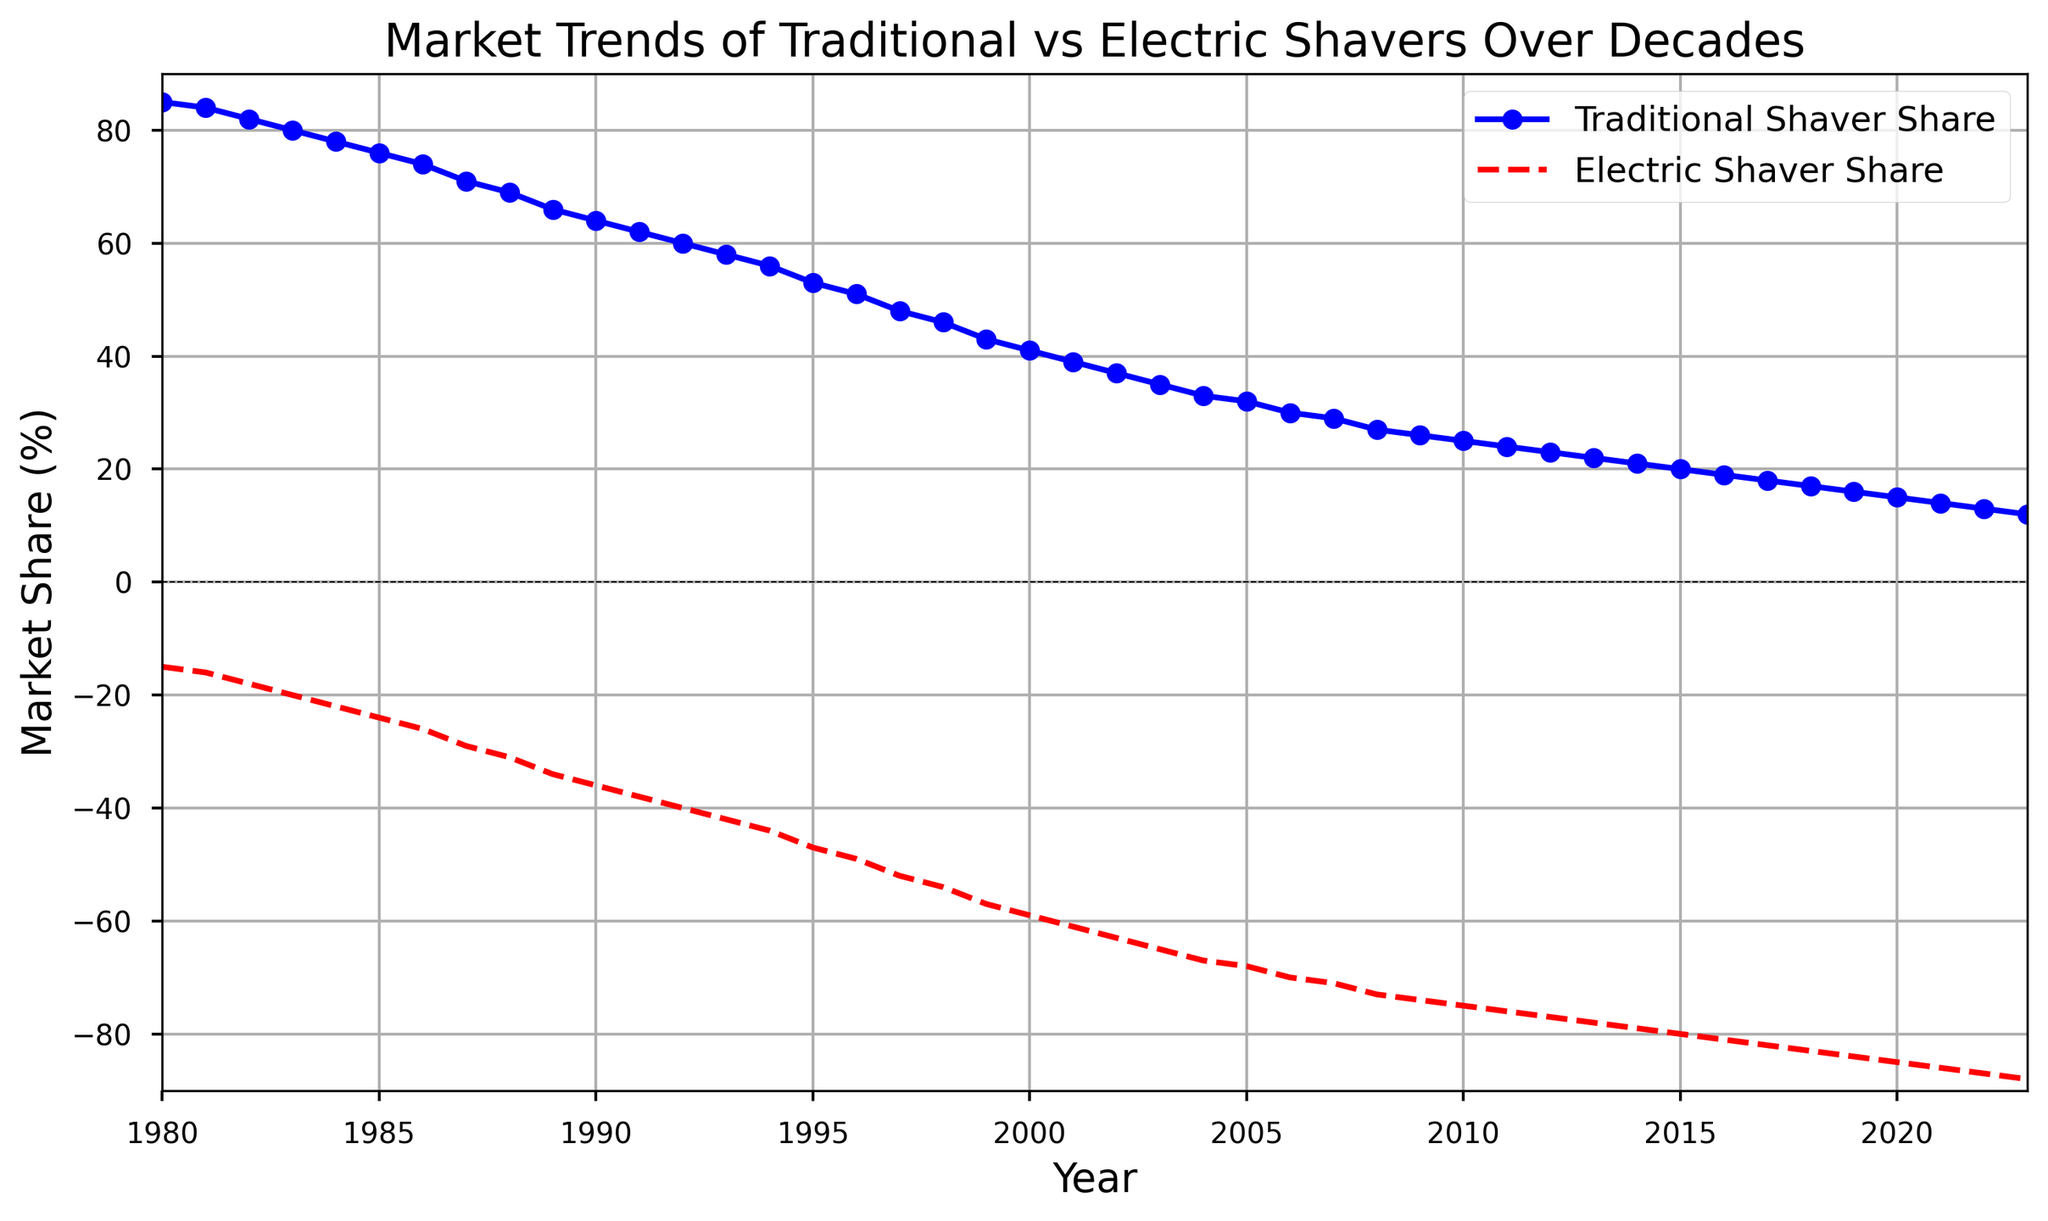What was the market share of traditional and electric shavers in 1990? In 1990, the point on the blue line (Traditional Shaver Share) shows a value of 64, while the point on the red dashed line (Electric Shaver Share) shows a value of -36.
Answer: Traditional: 64%, Electric: -36% Did the market share of traditional shavers ever increase from one year to the next? By observing the blue line (Traditional Shaver Share), it consistently decreases every year from 1980 to 2023, which indicates it never increases.
Answer: No What is the difference in market share between traditional and electric shavers in 2010? In 2010, the traditional shaver share is 25% and the electric shaver share is -75%. The difference is 25 - (-75), which equals 100.
Answer: 100% Which year had the highest market share for traditional shavers and what was it? The highest market share for traditional shavers is at the left end of the blue line (1980), with a value of 85.
Answer: 1980, 85% By how much did the market share of electric shavers decrease from 1980 to 2023? In 1980, the electric share is -15%, and in 2023, it is -88%. The decrease is -88 - (-15), which equals -73.
Answer: -73% What is the average market share for traditional shavers over the four years from 1980 to 1983? Sum the values for 1980 (85), 1981 (84), 1982 (82), and 1983 (80), which gives 331. Then divide by 4: 331/4.
Answer: 82.75% Compare the trend slopes of traditional and electric shavers between 2000 and 2010. Which had a more rapid change? For traditional: 41% (2000) to 25% (2010), change = 41 - 25 = 16. For electric: -59% (2000) to -75% (2010), change = -59 - (-75) = 16. Both changes are equal in magnitude.
Answer: Equal change rate 